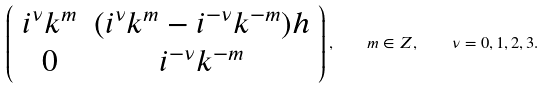<formula> <loc_0><loc_0><loc_500><loc_500>\left ( \begin{array} { c c } i ^ { \nu } k ^ { m } & ( i ^ { \nu } k ^ { m } - i ^ { - \nu } k ^ { - m } ) h \\ 0 & i ^ { - \nu } k ^ { - m } \end{array} \right ) , \quad m \in Z , \quad \nu = 0 , 1 , 2 , 3 .</formula> 